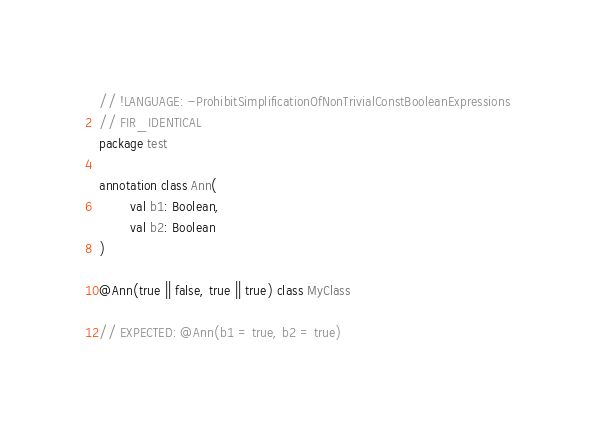<code> <loc_0><loc_0><loc_500><loc_500><_Kotlin_>// !LANGUAGE: -ProhibitSimplificationOfNonTrivialConstBooleanExpressions
// FIR_IDENTICAL
package test

annotation class Ann(
        val b1: Boolean,
        val b2: Boolean
)

@Ann(true || false, true || true) class MyClass

// EXPECTED: @Ann(b1 = true, b2 = true)
</code> 